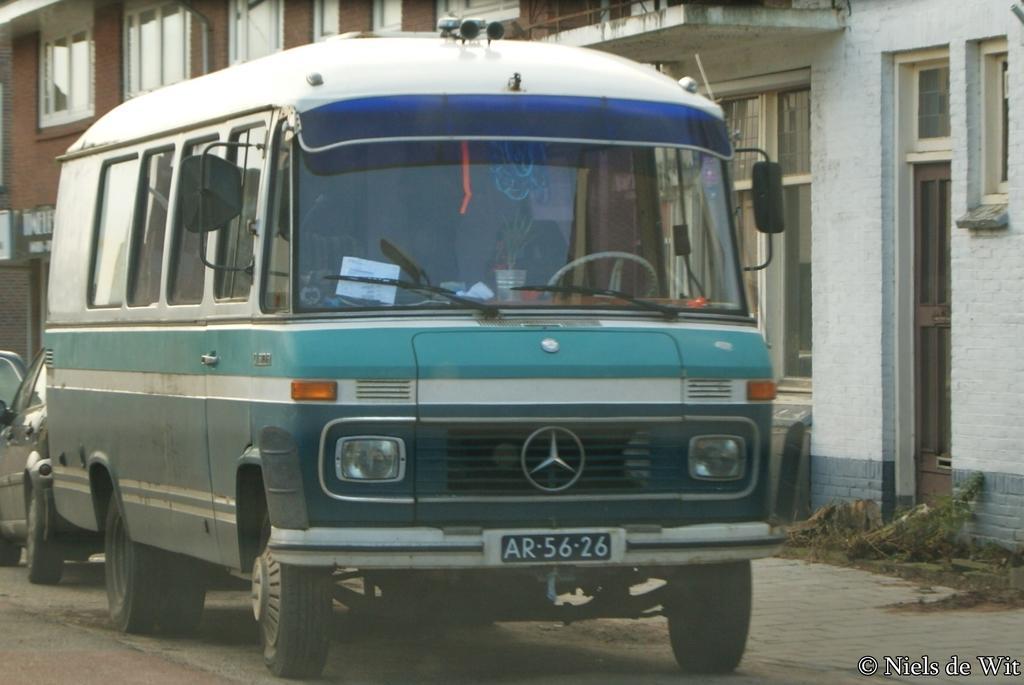In one or two sentences, can you explain what this image depicts? In this image we can see buildings with windows, vehicles and on the left hand side we can also see some text at the bottom. 